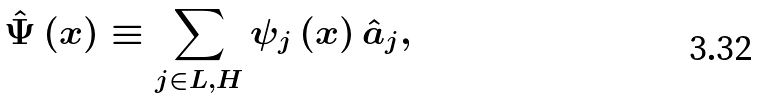<formula> <loc_0><loc_0><loc_500><loc_500>\hat { \Psi } \left ( { x } \right ) \equiv \sum _ { j \in L , H } \psi _ { j } \left ( { x } \right ) \hat { a } _ { j } ,</formula> 